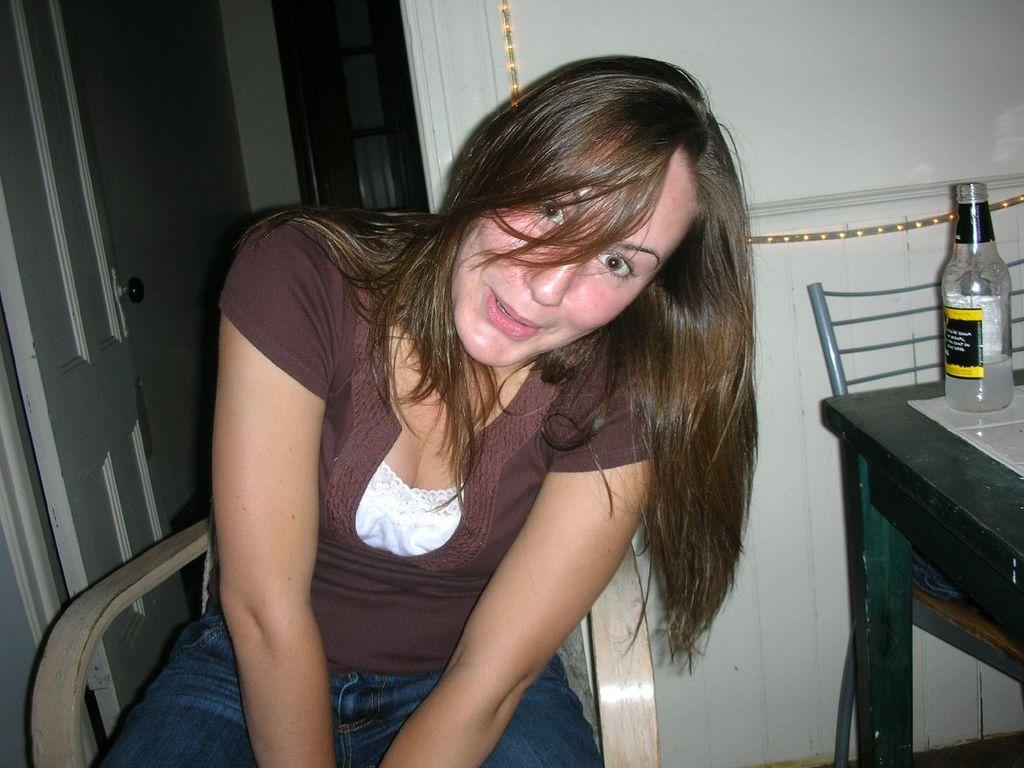Who is present in the image? There is a woman in the image. What is the woman doing in the image? The woman is sitting on a chair and smiling. What furniture is visible in the image? There is a table and a chair beside the table in the image. What object is on the table? There is a bottle on the table. What can be seen in the background of the image? There is a door visible in the background of the image. What type of apparatus is the woman using to communicate with the audience in the image? There is no apparatus visible in the image, and the woman is not communicating with an audience. What type of fork is the woman holding in the image? There is no fork present in the image. 